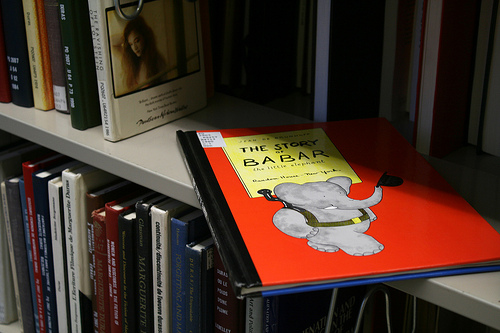<image>
Is the elephant on the book? Yes. Looking at the image, I can see the elephant is positioned on top of the book, with the book providing support. 